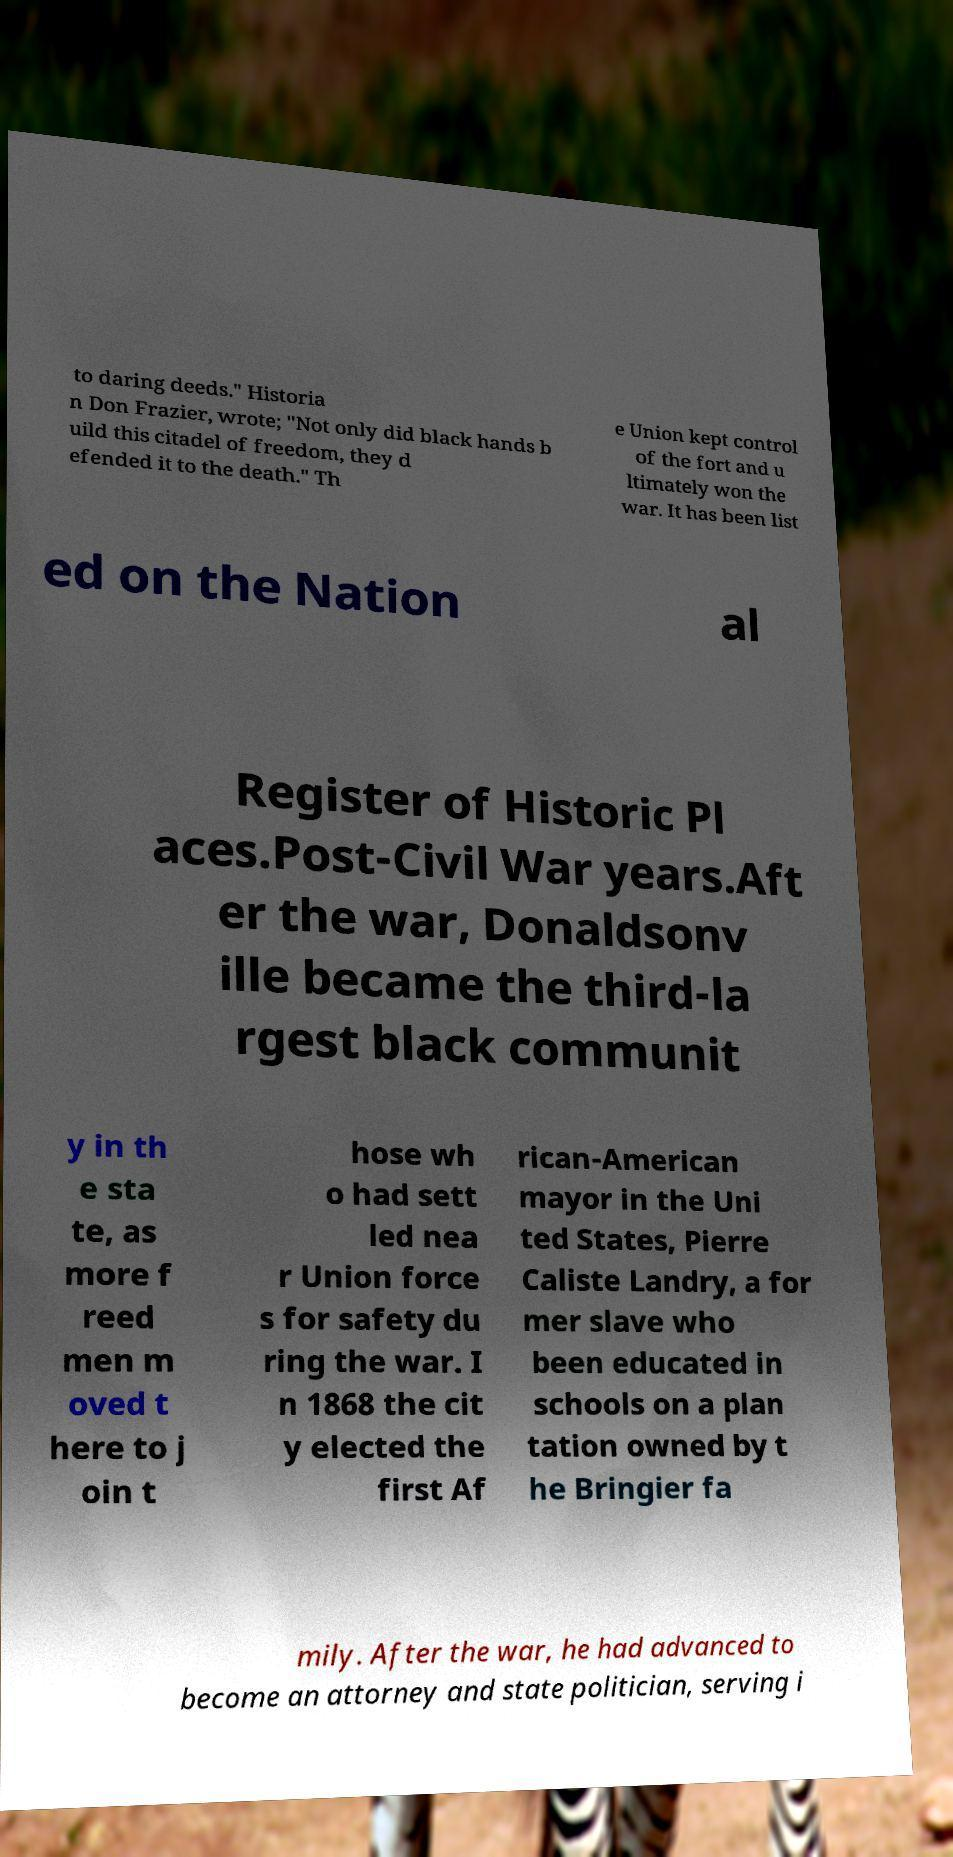Could you assist in decoding the text presented in this image and type it out clearly? to daring deeds." Historia n Don Frazier, wrote; "Not only did black hands b uild this citadel of freedom, they d efended it to the death." Th e Union kept control of the fort and u ltimately won the war. It has been list ed on the Nation al Register of Historic Pl aces.Post-Civil War years.Aft er the war, Donaldsonv ille became the third-la rgest black communit y in th e sta te, as more f reed men m oved t here to j oin t hose wh o had sett led nea r Union force s for safety du ring the war. I n 1868 the cit y elected the first Af rican-American mayor in the Uni ted States, Pierre Caliste Landry, a for mer slave who been educated in schools on a plan tation owned by t he Bringier fa mily. After the war, he had advanced to become an attorney and state politician, serving i 